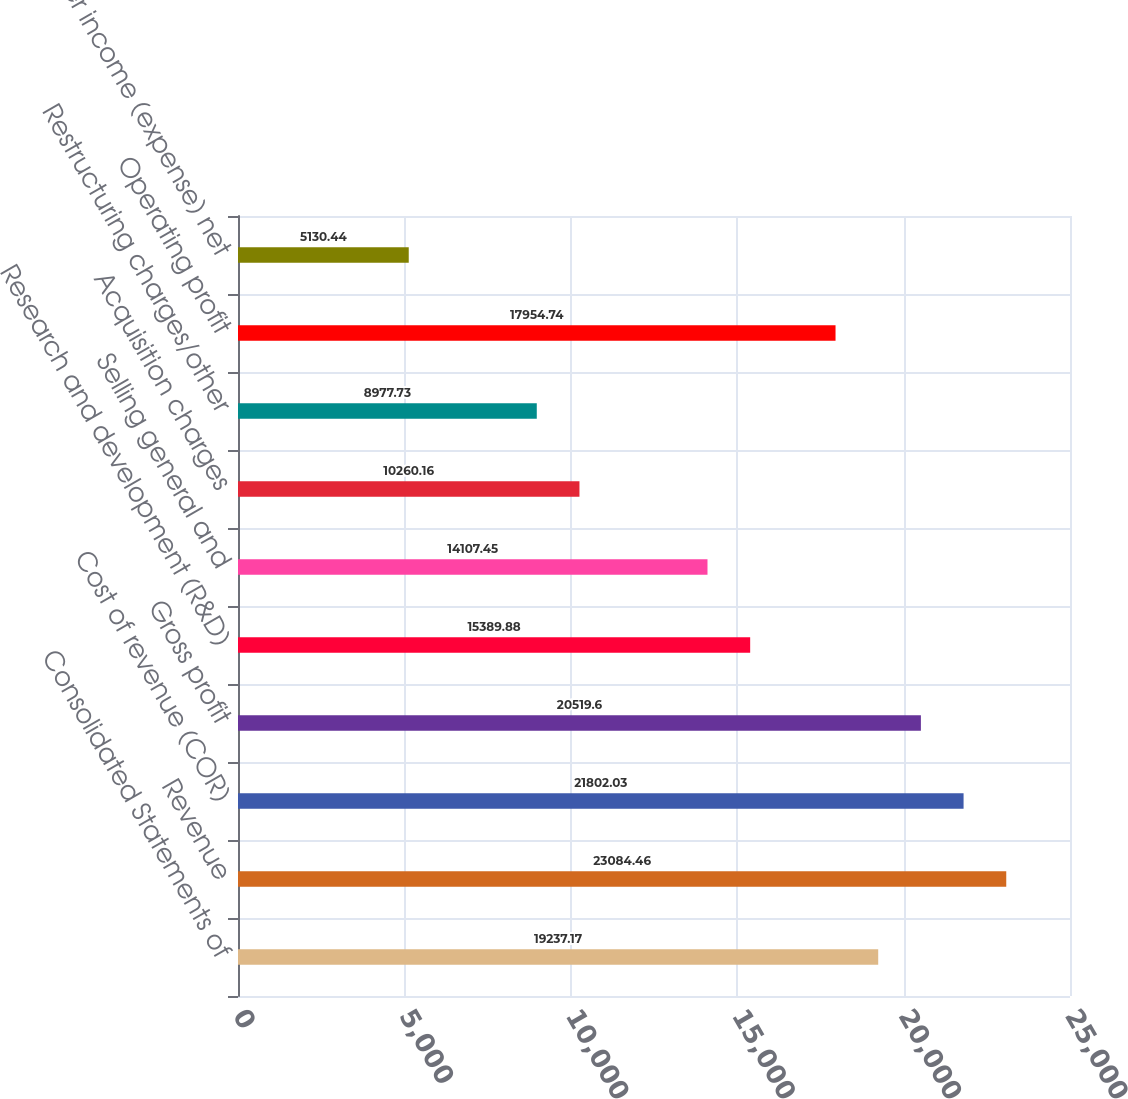Convert chart. <chart><loc_0><loc_0><loc_500><loc_500><bar_chart><fcel>Consolidated Statements of<fcel>Revenue<fcel>Cost of revenue (COR)<fcel>Gross profit<fcel>Research and development (R&D)<fcel>Selling general and<fcel>Acquisition charges<fcel>Restructuring charges/other<fcel>Operating profit<fcel>Other income (expense) net<nl><fcel>19237.2<fcel>23084.5<fcel>21802<fcel>20519.6<fcel>15389.9<fcel>14107.5<fcel>10260.2<fcel>8977.73<fcel>17954.7<fcel>5130.44<nl></chart> 